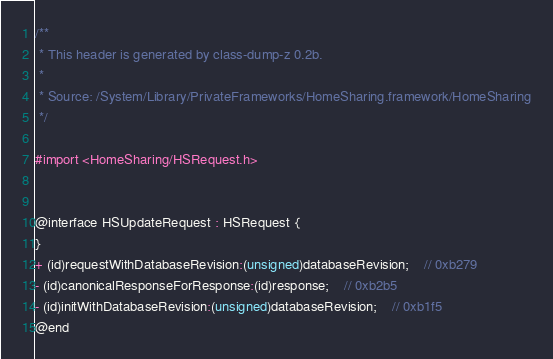Convert code to text. <code><loc_0><loc_0><loc_500><loc_500><_C_>/**
 * This header is generated by class-dump-z 0.2b.
 *
 * Source: /System/Library/PrivateFrameworks/HomeSharing.framework/HomeSharing
 */

#import <HomeSharing/HSRequest.h>


@interface HSUpdateRequest : HSRequest {
}
+ (id)requestWithDatabaseRevision:(unsigned)databaseRevision;	// 0xb279
- (id)canonicalResponseForResponse:(id)response;	// 0xb2b5
- (id)initWithDatabaseRevision:(unsigned)databaseRevision;	// 0xb1f5
@end
</code> 